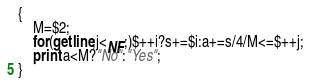Convert code to text. <code><loc_0><loc_0><loc_500><loc_500><_Awk_>{
    M=$2;
    for(getline;j<NF;)$++i?s+=$i:a+=s/4/M<=$++j;
    print a<M?"No":"Yes";
}</code> 